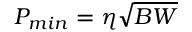<formula> <loc_0><loc_0><loc_500><loc_500>P _ { \min } = \eta \sqrt { B W }</formula> 